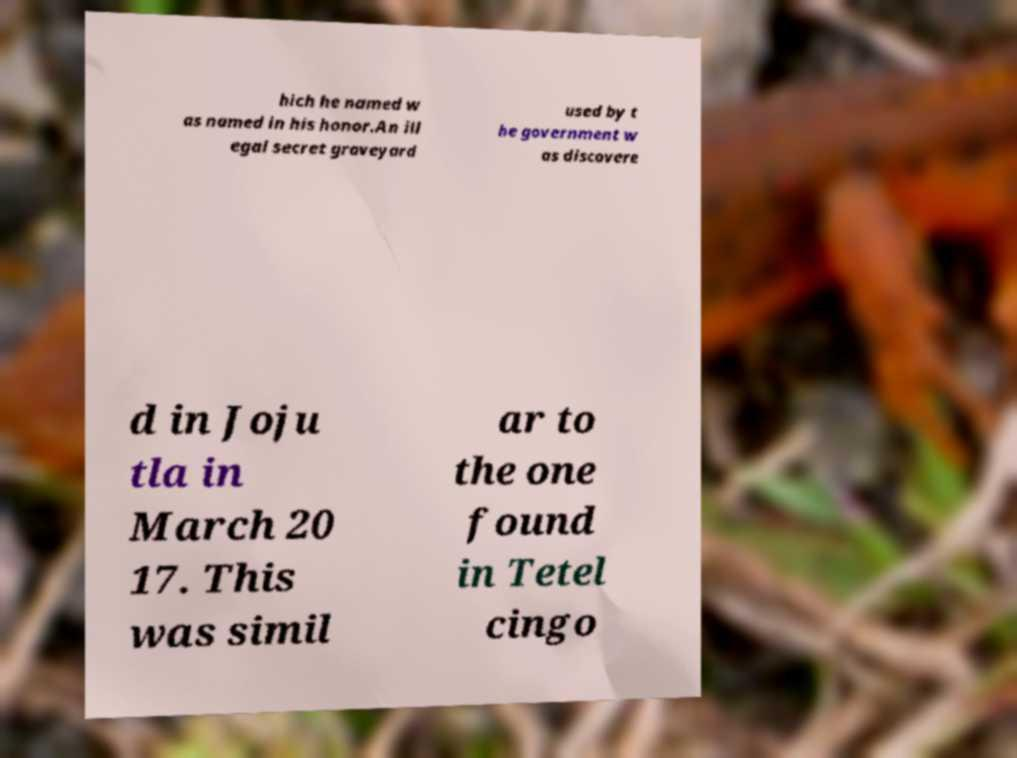Can you accurately transcribe the text from the provided image for me? hich he named w as named in his honor.An ill egal secret graveyard used by t he government w as discovere d in Joju tla in March 20 17. This was simil ar to the one found in Tetel cingo 